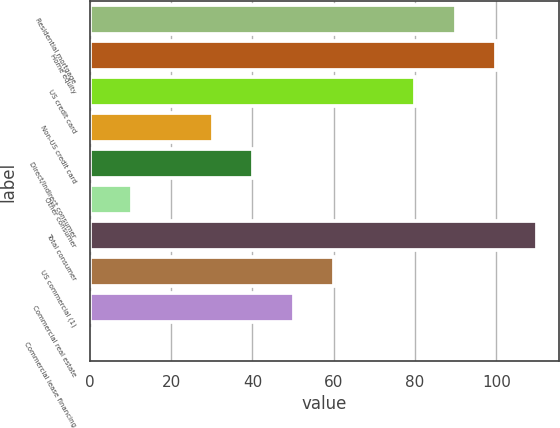Convert chart. <chart><loc_0><loc_0><loc_500><loc_500><bar_chart><fcel>Residential mortgage<fcel>Home equity<fcel>US credit card<fcel>Non-US credit card<fcel>Direct/Indirect consumer<fcel>Other consumer<fcel>Total consumer<fcel>US commercial (1)<fcel>Commercial real estate<fcel>Commercial lease financing<nl><fcel>90<fcel>99.97<fcel>80.03<fcel>30.18<fcel>40.15<fcel>10.24<fcel>109.94<fcel>60.09<fcel>50.12<fcel>0.27<nl></chart> 